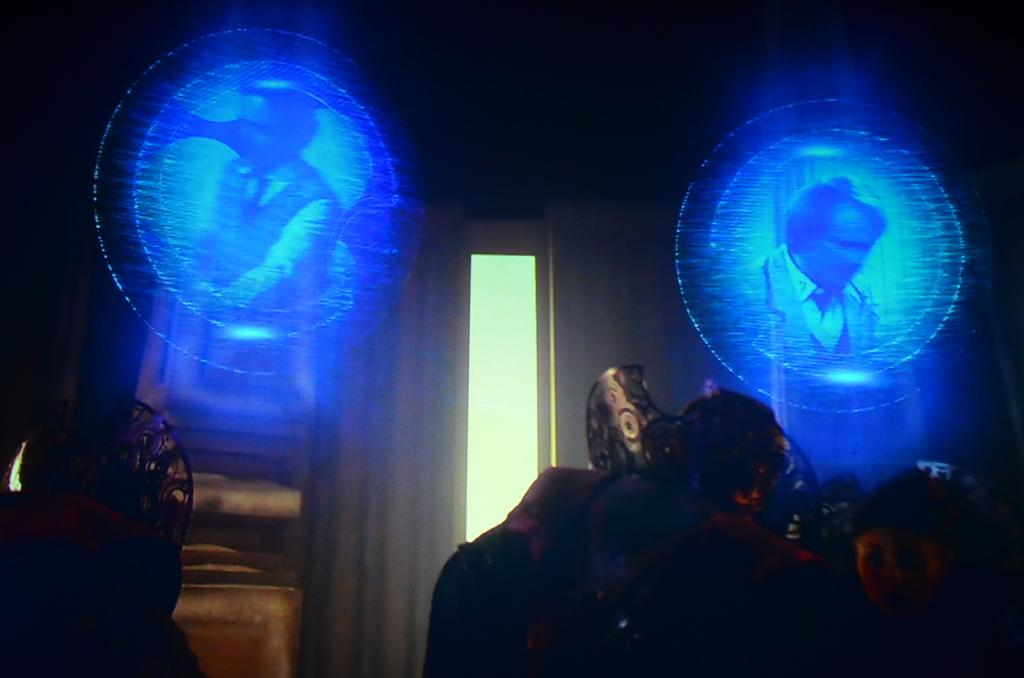What is the main subject of the image? There is a sculpture in the image. Are there any people present in the image? Yes, there is a person in the image. What other objects can be seen in the image? There are screens in the image. How would you describe the overall appearance of the image? The background of the image is dark. What type of mask is the person wearing in the image? There is no mask present in the image; the person is not wearing one. What flavor of ice cream does the sculpture represent? The sculpture does not represent any flavor of ice cream, as it is not an edible object. 